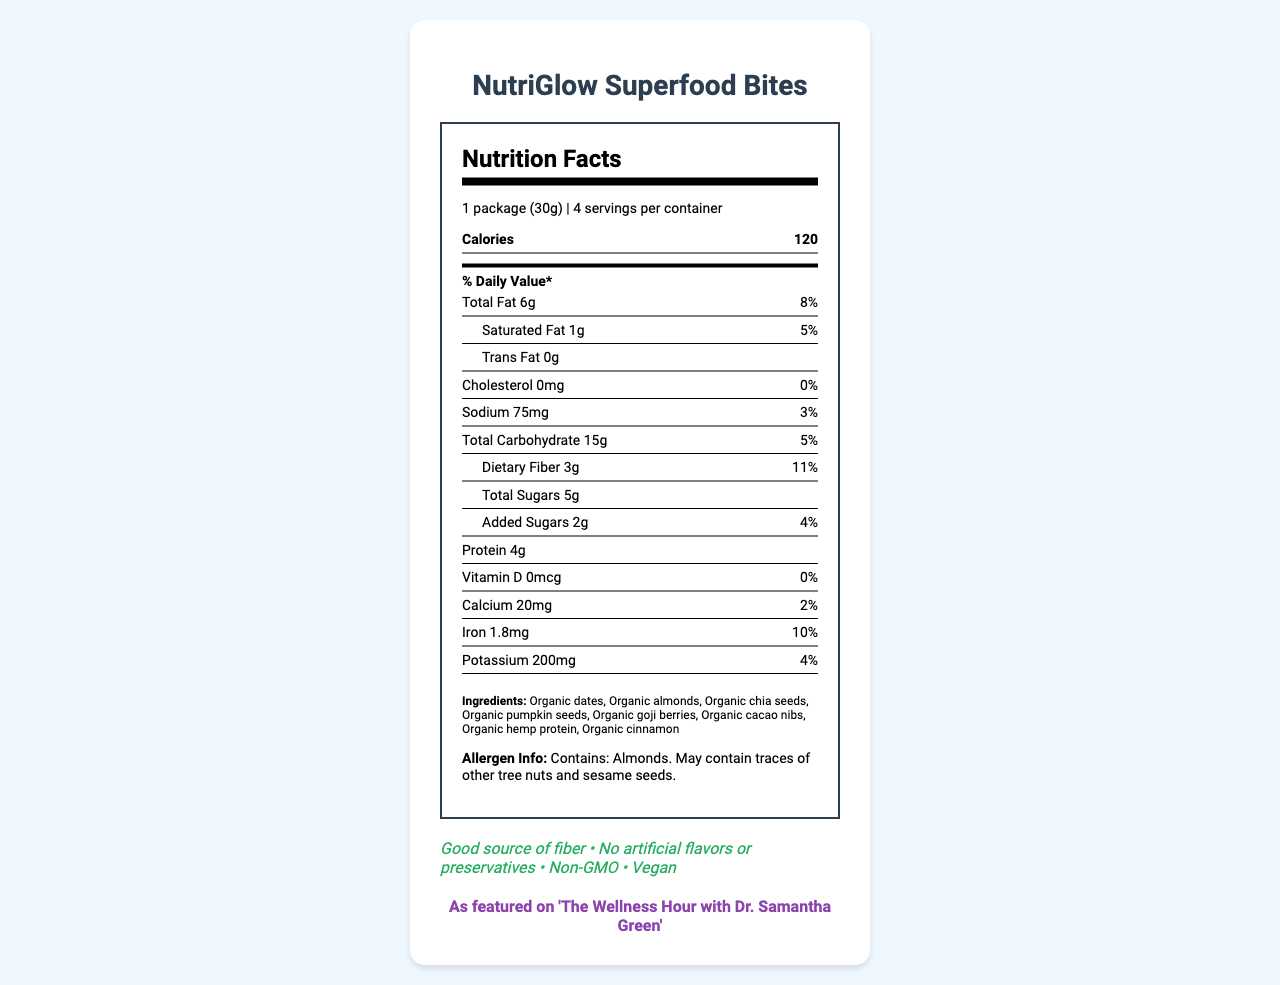what is the name of the product? The name of the product is prominently displayed at the top of the document.
Answer: NutriGlow Superfood Bites What is the serving size? The serving size is listed in the serving info section of the nutrition label as "1 package (30g)".
Answer: 1 package (30g) How many calories are in one serving? The nutrition label lists the calories per serving as 120.
Answer: 120 How much protein is in one serving? The nutrition facts indicate that there are 4g of protein per serving.
Answer: 4g Which ingredient is listed first in the ingredients list? The first item in the ingredients list is "Organic dates".
Answer: Organic dates What is the daily value percentage for dietary fiber? The daily value percentage for dietary fiber is indicated as 11% in the nutrition label.
Answer: 11% How much calcium is in one serving? The nutrition label lists calcium content as 20mg per serving.
Answer: 20mg Does the product contain any artificial flavors or preservatives? The health claims section states "No artificial flavors or preservatives".
Answer: No (Multiple choice) Which of the following health claims is NOT mentioned in the document? A. Organic B. Good source of fiber C. Non-GMO D. Vegan The document mentions "Good source of fiber", "Non-GMO", and "Vegan" but does not specifically mention the product being organic.
Answer: A (Multiple choice) How much iron is in one serving of NutriGlow Superfood Bites? I. 0.5mg II. 1.0mg III. 1.8mg IV. 2.5mg The nutrition label indicates that there is 1.8mg of iron per serving.
Answer: III (True/False) The packaging of NutriGlow Superfood Bites is made from recyclable material. The document states the packaging is "Eco-friendly, compostable wrapper" but does not mention it being recyclable.
Answer: False Summarize the main idea of the document. The document provides detailed nutritional information, ingredients, health claims, allergen info, target audience, and how the product will be integrated into a wellness segment on a talk show.
Answer: NutriGlow Superfood Bites are a healthy, nutrient-dense snack designed for health-conscious adults, offering benefits like high fiber content, no artificial ingredients, and eco-friendly packaging, with endorsement from a health-focused talk show. What is the total amount of added sugars in all servings of the package? The document only provides the amount of added sugars per serving (2g) but doesn't multiply it across all servings in the package.
Answer: Cannot be determined What age group is the target audience for this product? The target audience specified in the document is health-conscious adults aged 25-54.
Answer: 25-54 Which celebrity endorses the NutriGlow Superfood Bites? The celebrity endorsement section mentions that the product is featured on 'The Wellness Hour with Dr. Samantha Green'.
Answer: Dr. Samantha Green 